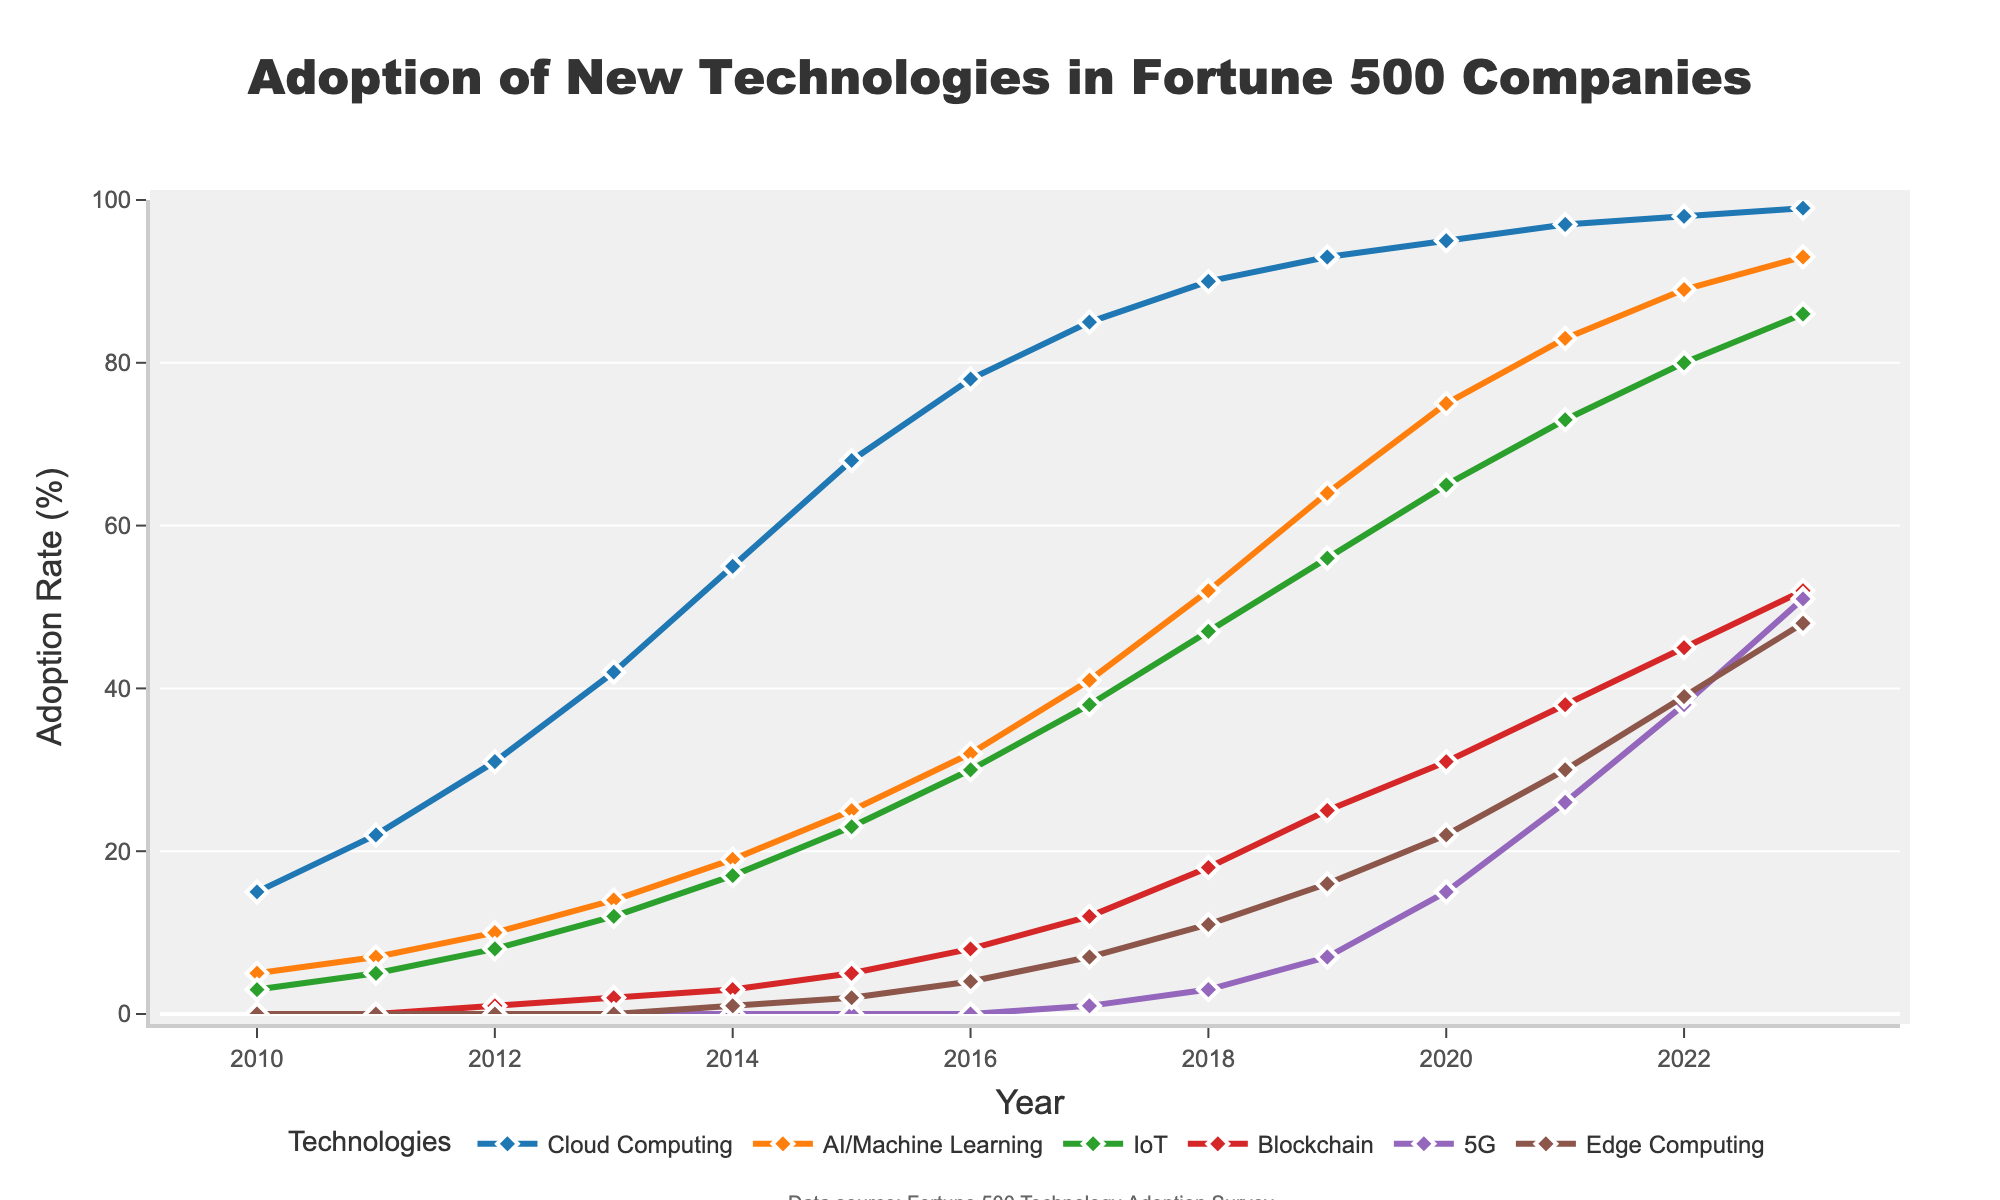What is the adoption rate of Cloud Computing in 2015? Refer to the line chart and find the point corresponding to the year 2015 under the Cloud Computing line.
Answer: 68 Which technology had the highest adoption rate in 2023? Look at the endpoints of all lines in 2023 and identify which one is the highest.
Answer: Cloud Computing How did the adoption rate of AI/Machine Learning change from 2010 to 2023? Calculate the difference between the adoption rate of AI/Machine Learning in 2023 and 2010.
Answer: Increased by 88 Compare the adoption rates of IoT and Blockchain in 2018. Which was higher? Find and compare the adoption rates for IoT and Blockchain in 2018 from their respective lines.
Answer: IoT What is the average adoption rate of 5G from 2020 to 2023? Sum the adoption rates of 5G for years 2020, 2021, 2022, and 2023, then divide by 4.
Answer: 32.5 By what percentage did Edge Computing adoption increase from 2014 to 2019? Calculate the difference between the values in 2019 and 2014 for Edge Computing, and divide that by the value in 2014, then multiply by 100.
Answer: 1500% What adoption rate did Blockchain reach by 2017? Look at the figure for Blockchain corresponding to the year 2017.
Answer: 12 Which technology saw the most significant rise between 2011 and 2013? Calculate the increase for each technology between 2011 and 2013 and compare.
Answer: Cloud Computing In which year did IoT adoption surpass 50%? Find the year when the IoT line crosses the 50% mark.
Answer: 2019 Identify the technology that had the least adoption in 2013. Compare the values of all technologies in 2013 and identify the smallest one.
Answer: 5G 